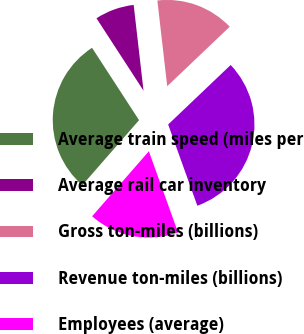Convert chart to OTSL. <chart><loc_0><loc_0><loc_500><loc_500><pie_chart><fcel>Average train speed (miles per<fcel>Average rail car inventory<fcel>Gross ton-miles (billions)<fcel>Revenue ton-miles (billions)<fcel>Employees (average)<nl><fcel>29.41%<fcel>7.35%<fcel>14.71%<fcel>31.62%<fcel>16.91%<nl></chart> 